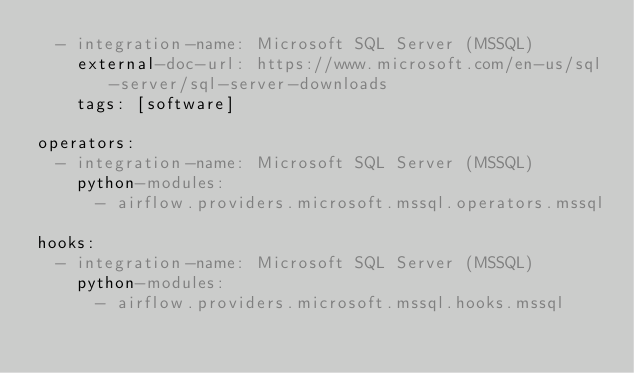Convert code to text. <code><loc_0><loc_0><loc_500><loc_500><_YAML_>  - integration-name: Microsoft SQL Server (MSSQL)
    external-doc-url: https://www.microsoft.com/en-us/sql-server/sql-server-downloads
    tags: [software]

operators:
  - integration-name: Microsoft SQL Server (MSSQL)
    python-modules:
      - airflow.providers.microsoft.mssql.operators.mssql

hooks:
  - integration-name: Microsoft SQL Server (MSSQL)
    python-modules:
      - airflow.providers.microsoft.mssql.hooks.mssql
</code> 